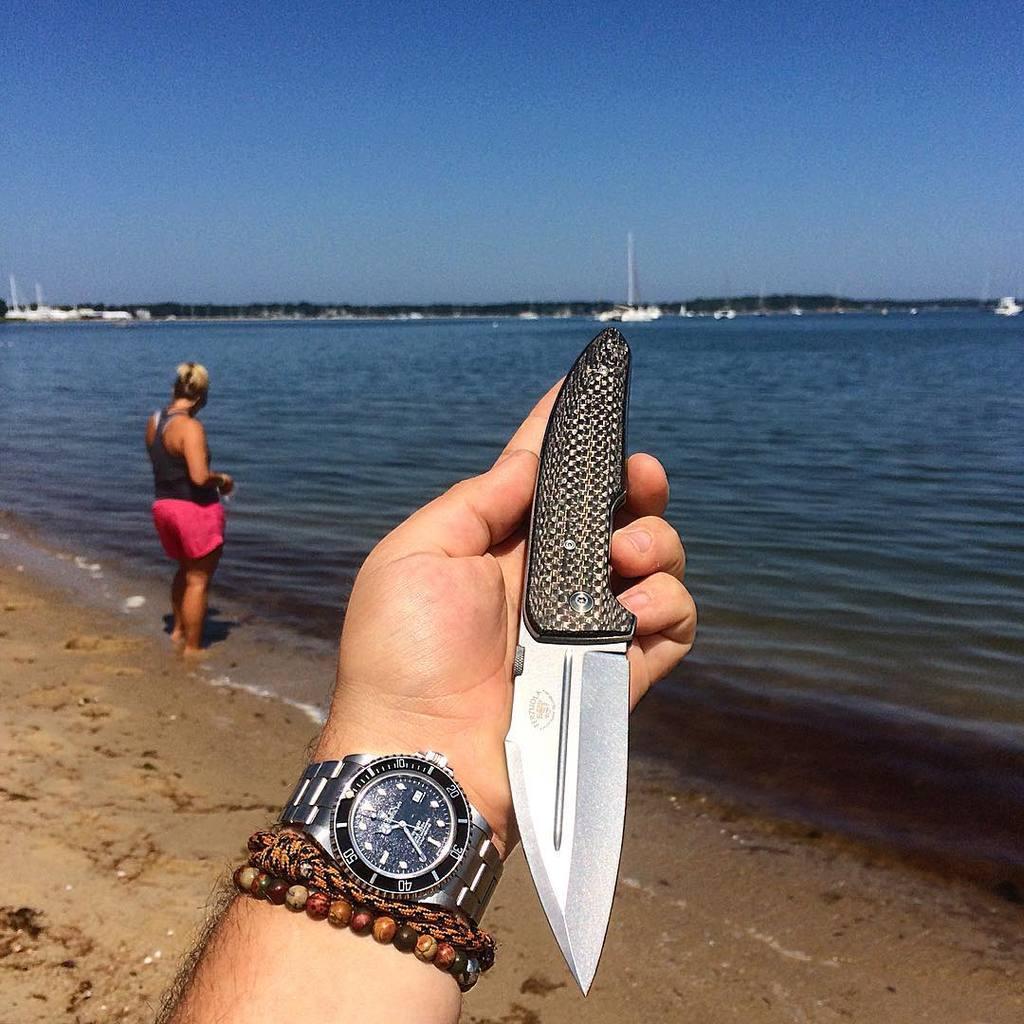What is one of the numbers shown on the watch?
Offer a terse response. 40. What time is on the watch?
Provide a succinct answer. 10:35. 